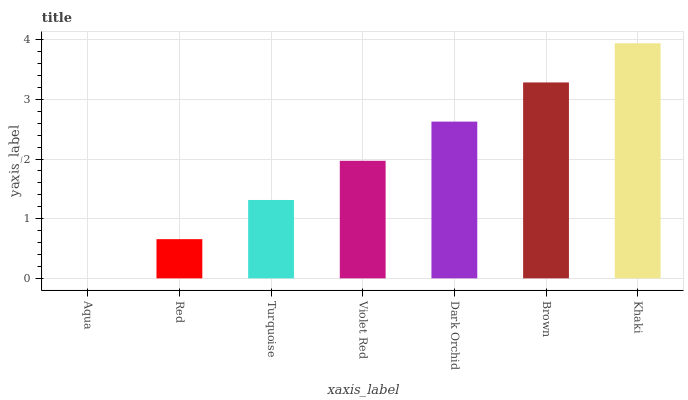Is Aqua the minimum?
Answer yes or no. Yes. Is Khaki the maximum?
Answer yes or no. Yes. Is Red the minimum?
Answer yes or no. No. Is Red the maximum?
Answer yes or no. No. Is Red greater than Aqua?
Answer yes or no. Yes. Is Aqua less than Red?
Answer yes or no. Yes. Is Aqua greater than Red?
Answer yes or no. No. Is Red less than Aqua?
Answer yes or no. No. Is Violet Red the high median?
Answer yes or no. Yes. Is Violet Red the low median?
Answer yes or no. Yes. Is Dark Orchid the high median?
Answer yes or no. No. Is Turquoise the low median?
Answer yes or no. No. 